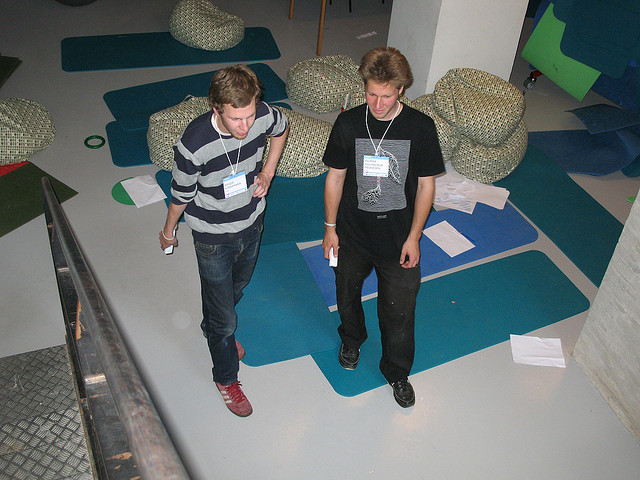<image>What kind of hat is this guy wearing? This guy is not wearing a hat. What game console are the boys playing on? I am not sure what game console the boys are playing on. It could possibly be a Wii or Nintendo Wii. What game console are the boys playing on? The boys are playing on the Wii game console. What kind of hat is this guy wearing? It is not clear what kind of hat the guy is wearing. It seems that he is not wearing any hat. 